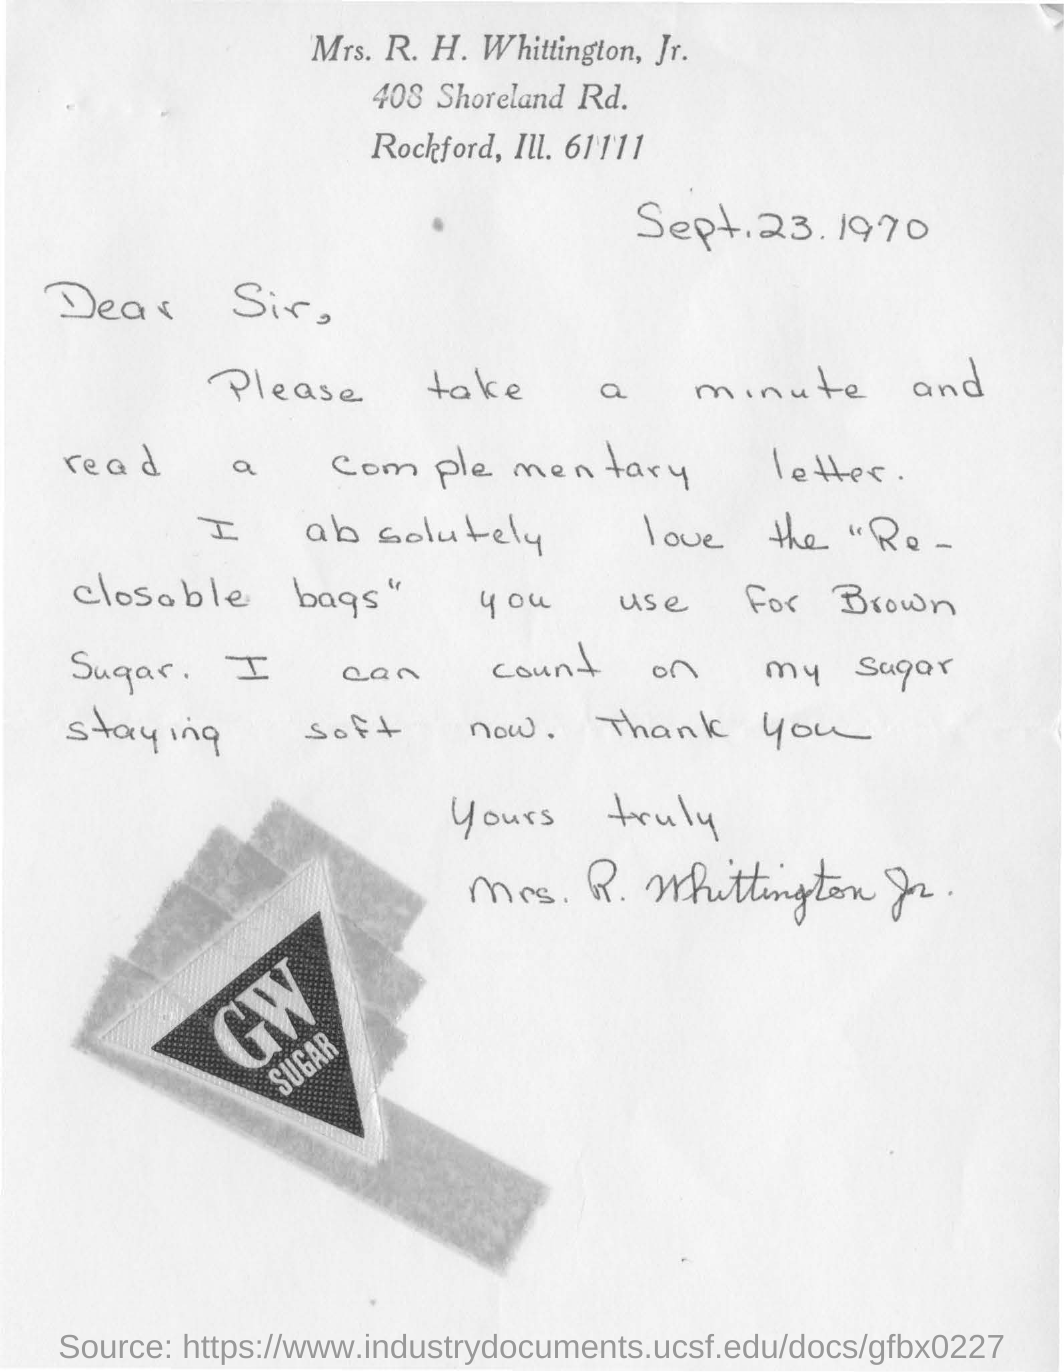What is the date mentioned in this letter?
Ensure brevity in your answer.  Sept.23.1970. Who wrote the letter?
Give a very brief answer. Mrs. R. H. whittington, Jr. What sugar is mentioned in the letter?
Ensure brevity in your answer.  Brown Sugar. 